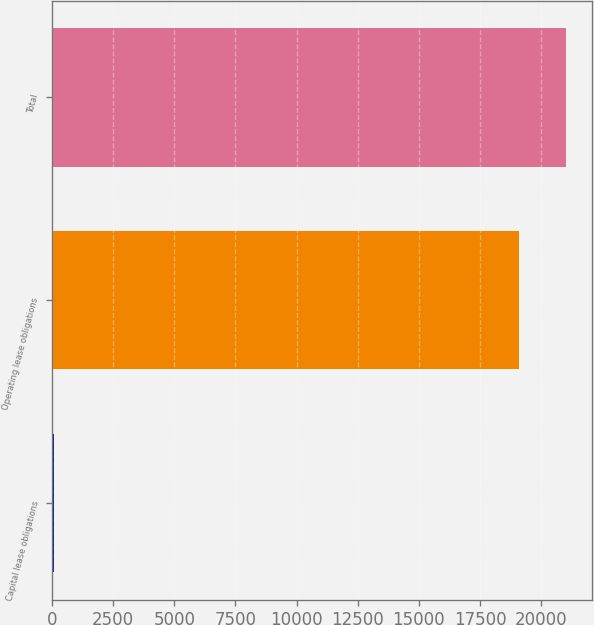<chart> <loc_0><loc_0><loc_500><loc_500><bar_chart><fcel>Capital lease obligations<fcel>Operating lease obligations<fcel>Total<nl><fcel>87<fcel>19102<fcel>21012.2<nl></chart> 